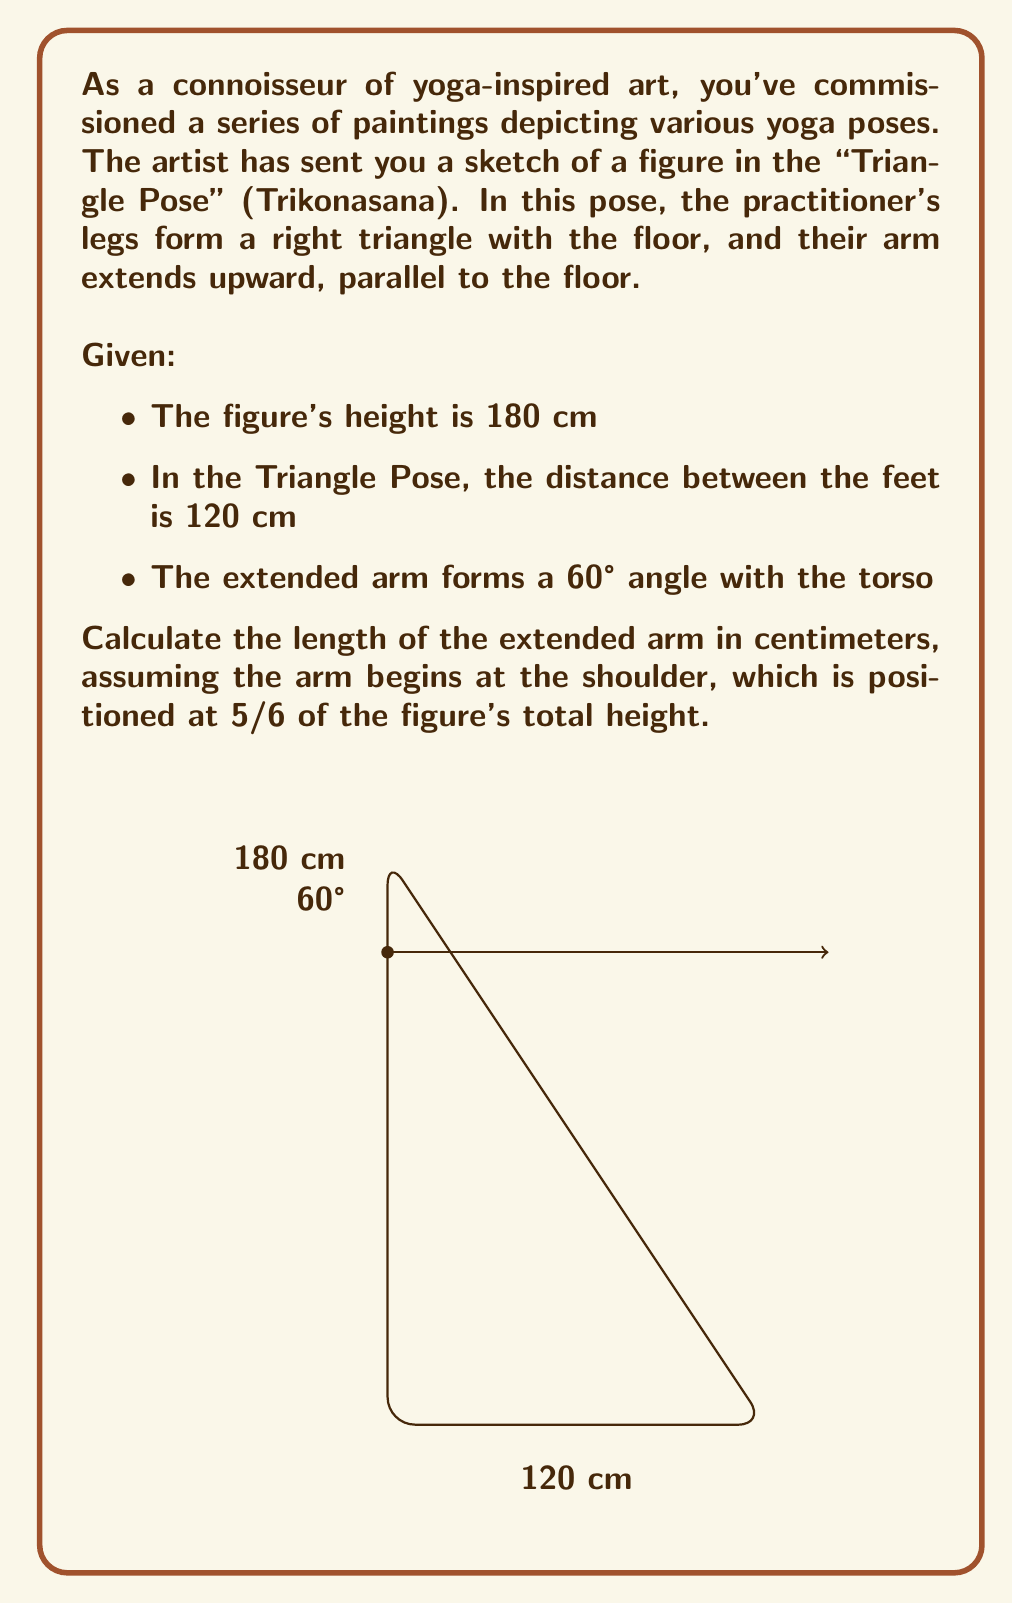What is the answer to this math problem? Let's approach this step-by-step:

1) First, we need to find the height of the shoulder:
   $\text{Shoulder height} = \frac{5}{6} \times 180 \text{ cm} = 150 \text{ cm}$

2) Now, we have a right triangle. We know:
   - The base (distance between feet) is 120 cm
   - The height (from floor to shoulder) is 150 cm

3) We can find the length of the torso (hypotenuse) using the Pythagorean theorem:
   $$\text{Torso}^2 = 120^2 + 150^2$$
   $$\text{Torso} = \sqrt{14400 + 22500} = \sqrt{36900} = 192.09 \text{ cm}$$

4) Now, we have a new triangle formed by the torso and the extended arm, with a 60° angle between them. This is a 30-60-90 triangle.

5) In a 30-60-90 triangle, if the hypotenuse (torso) is $x$, then:
   - The shorter leg (arm) is $\frac{x}{2}$
   - The longer leg is $\frac{x\sqrt{3}}{2}$

6) Therefore, the length of the arm is:
   $$\text{Arm length} = \frac{192.09}{2} = 96.045 \text{ cm}$$

7) Rounding to the nearest centimeter:
   $$\text{Arm length} \approx 96 \text{ cm}$$
Answer: 96 cm 